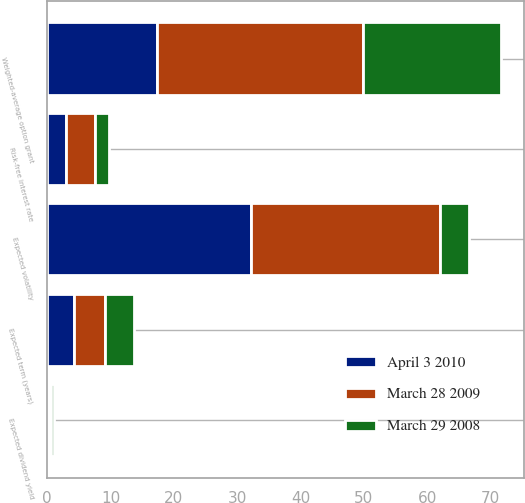Convert chart to OTSL. <chart><loc_0><loc_0><loc_500><loc_500><stacked_bar_chart><ecel><fcel>Expected term (years)<fcel>Expected volatility<fcel>Expected dividend yield<fcel>Risk-free interest rate<fcel>Weighted-average option grant<nl><fcel>March 29 2008<fcel>4.6<fcel>4.6<fcel>0.46<fcel>2.2<fcel>21.77<nl><fcel>April 3 2010<fcel>4.3<fcel>32.1<fcel>0.29<fcel>3<fcel>17.27<nl><fcel>March 28 2009<fcel>4.8<fcel>29.9<fcel>0.26<fcel>4.6<fcel>32.65<nl></chart> 